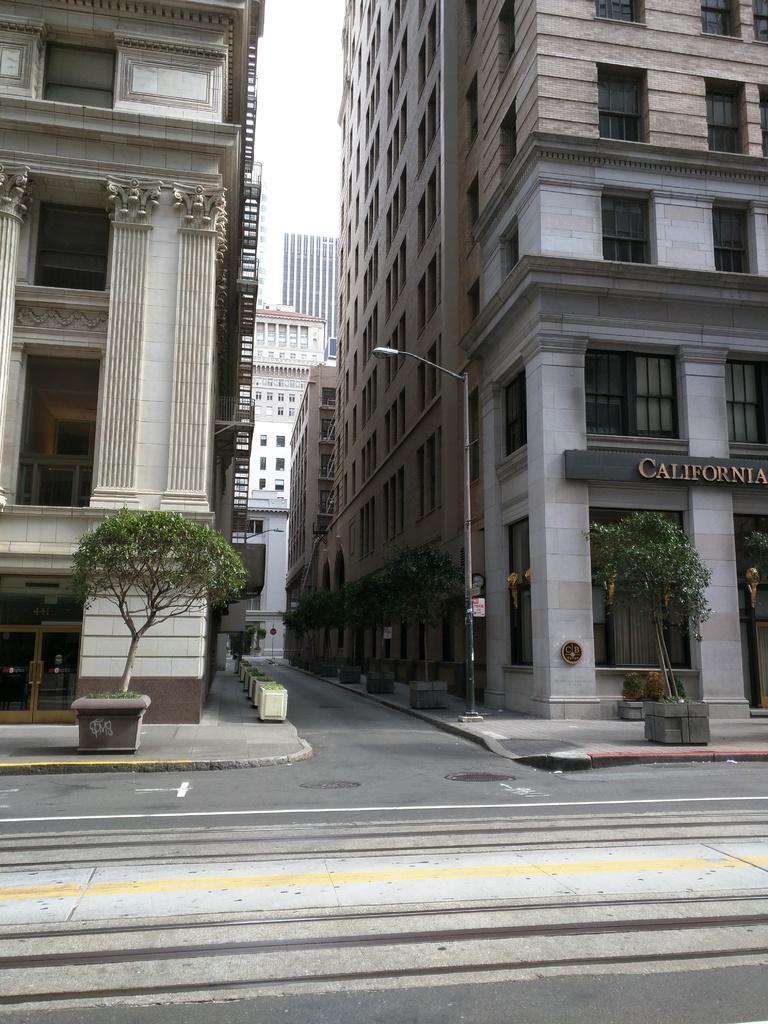Describe this image in one or two sentences. This image is clicked on the roads. On the left and right, there are buildings. And we can see small potted plants in the front. At the top, there is sky. And there are many windows to the building. 